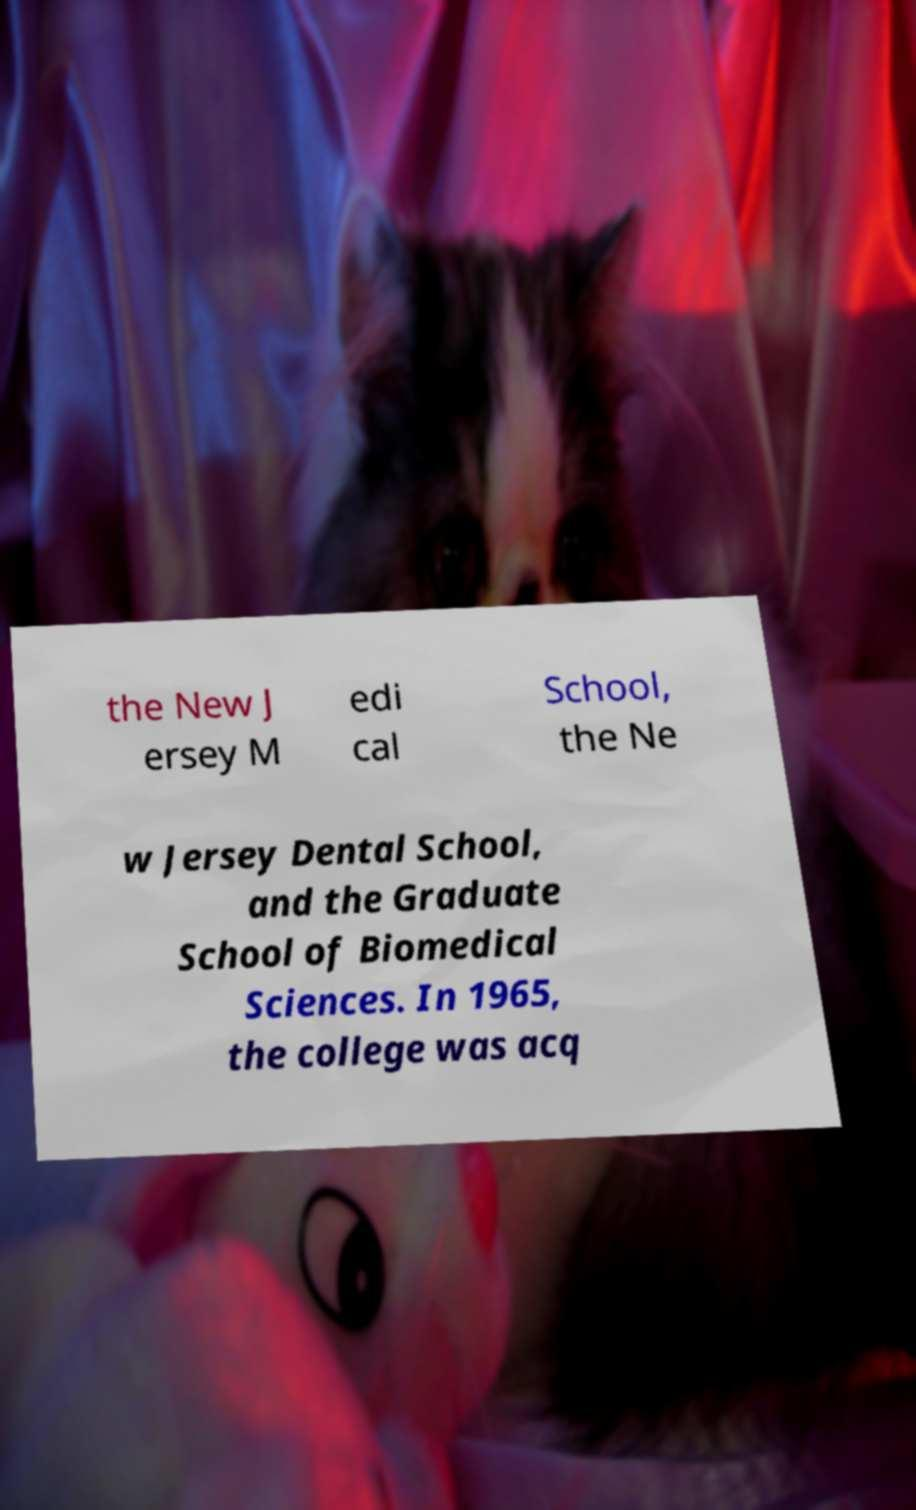I need the written content from this picture converted into text. Can you do that? the New J ersey M edi cal School, the Ne w Jersey Dental School, and the Graduate School of Biomedical Sciences. In 1965, the college was acq 